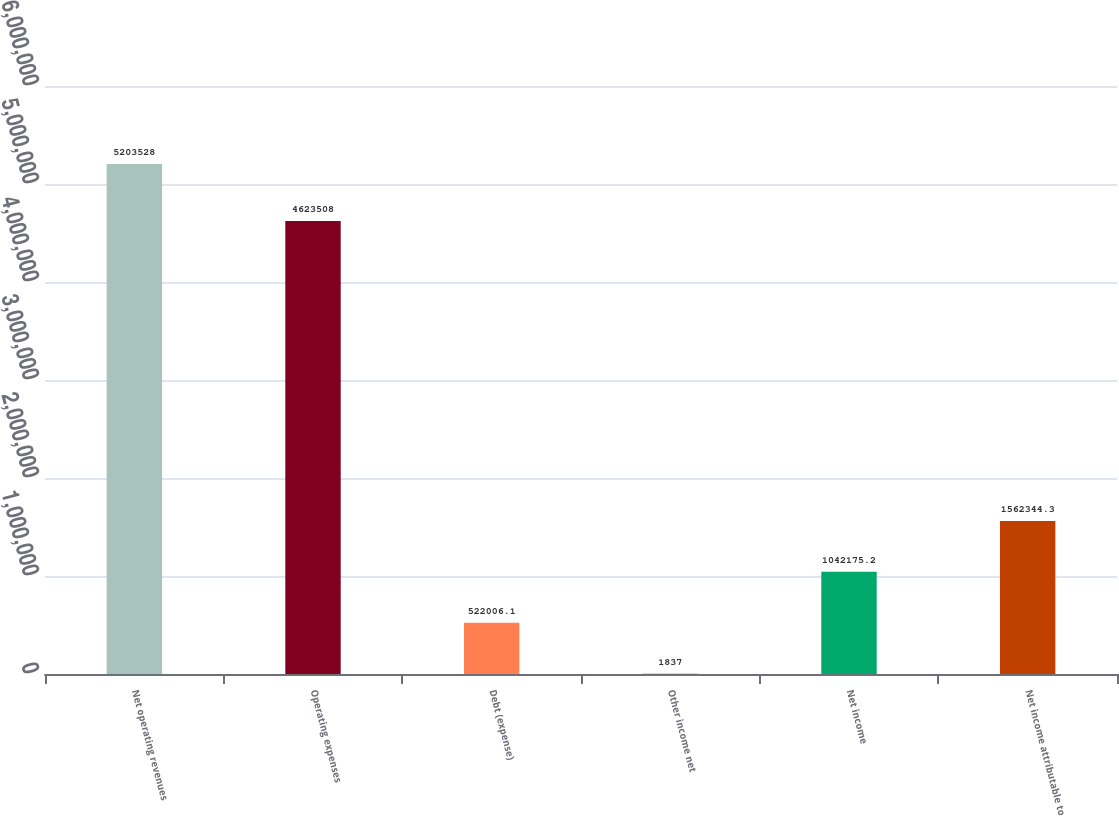Convert chart to OTSL. <chart><loc_0><loc_0><loc_500><loc_500><bar_chart><fcel>Net operating revenues<fcel>Operating expenses<fcel>Debt (expense)<fcel>Other income net<fcel>Net income<fcel>Net income attributable to<nl><fcel>5.20353e+06<fcel>4.62351e+06<fcel>522006<fcel>1837<fcel>1.04218e+06<fcel>1.56234e+06<nl></chart> 